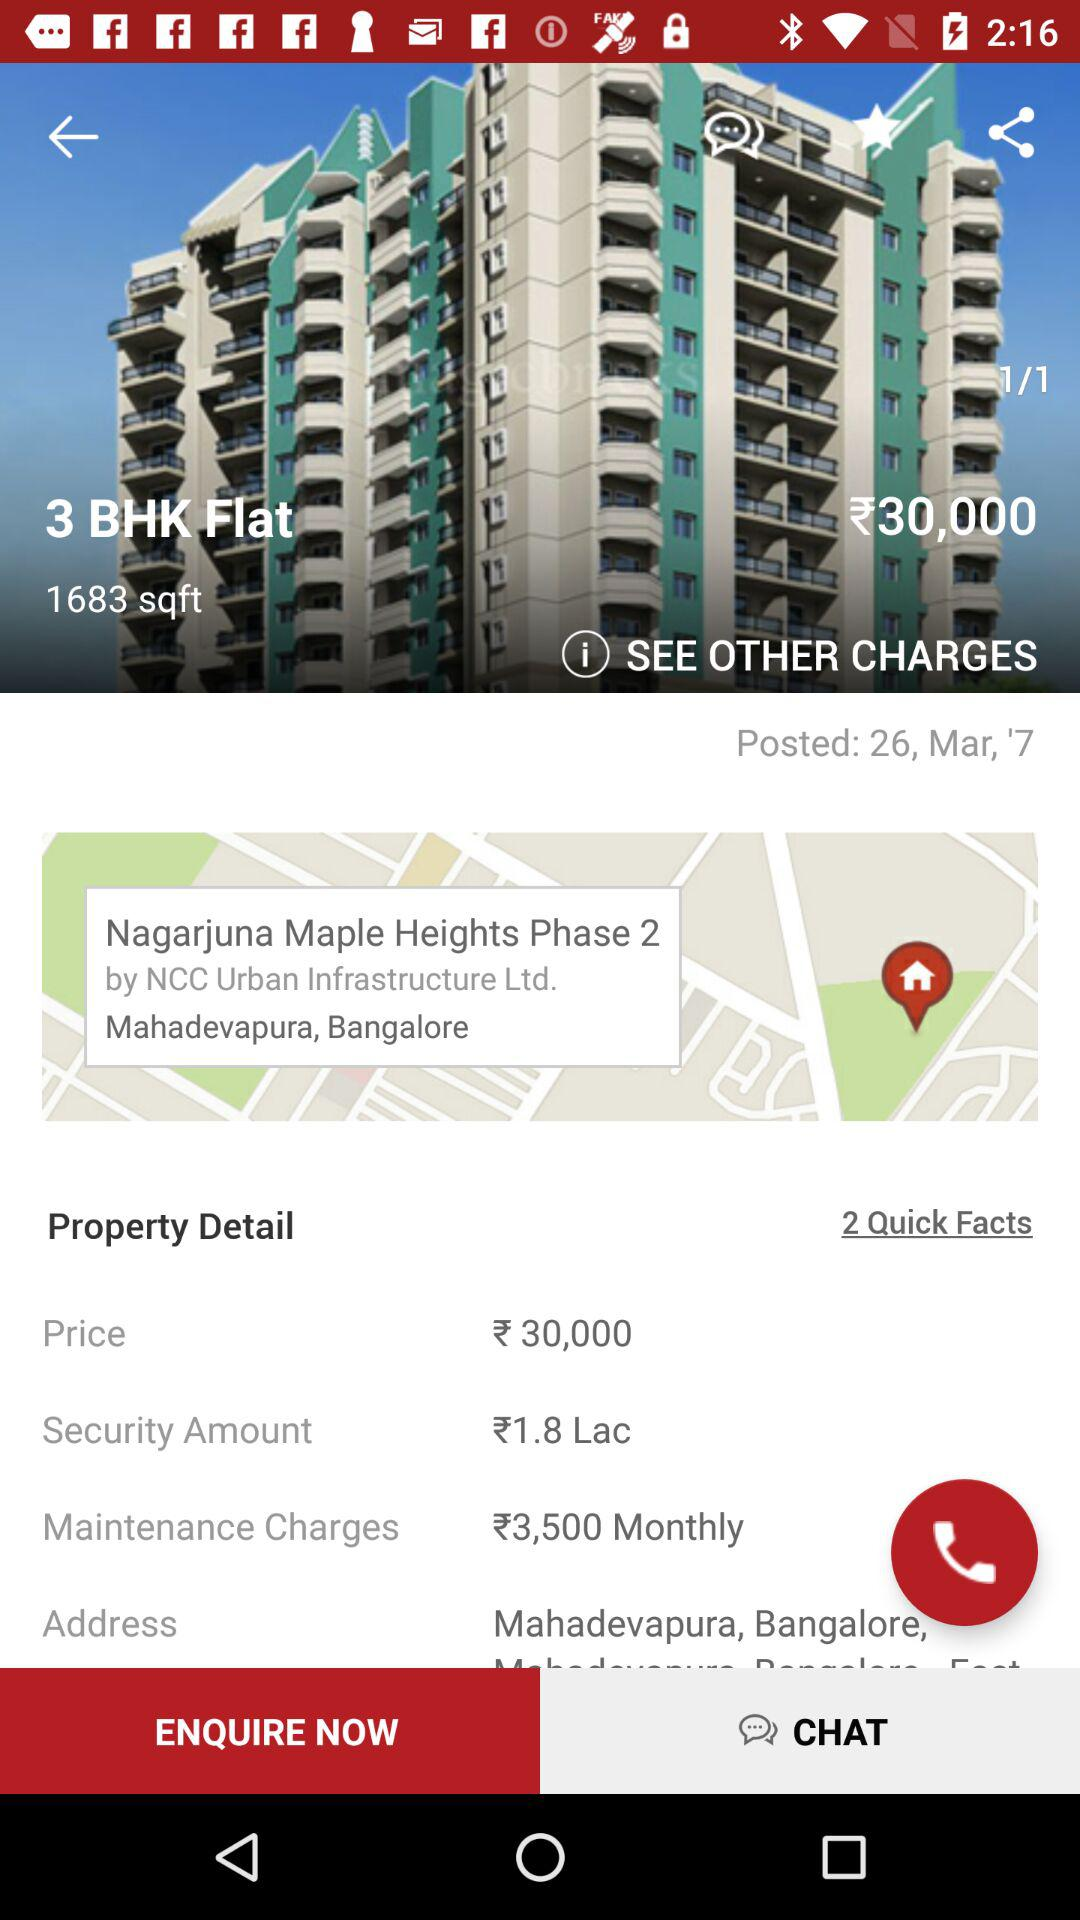How much is the security amount in lakhs?
Answer the question using a single word or phrase. 1.8 